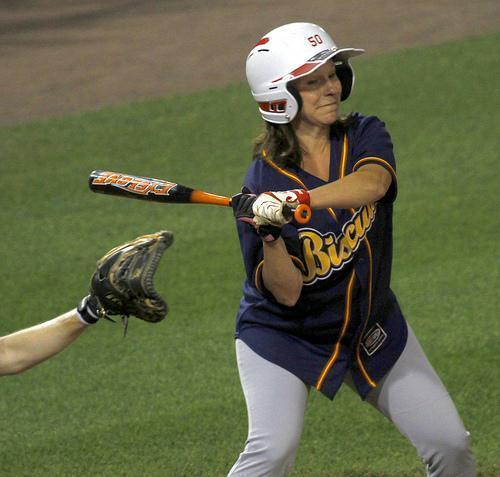How many batters are there?
Give a very brief answer. 1. 